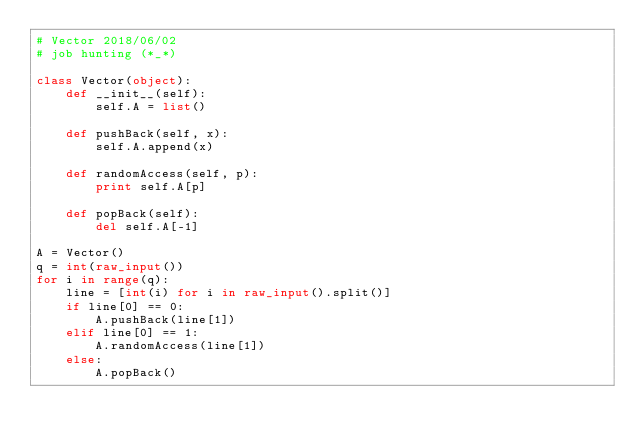Convert code to text. <code><loc_0><loc_0><loc_500><loc_500><_Python_># Vector 2018/06/02
# job hunting (*_*)

class Vector(object):
    def __init__(self):
        self.A = list()

    def pushBack(self, x):
        self.A.append(x)

    def randomAccess(self, p):
        print self.A[p]

    def popBack(self):
        del self.A[-1]

A = Vector()
q = int(raw_input())
for i in range(q):
    line = [int(i) for i in raw_input().split()]
    if line[0] == 0:
        A.pushBack(line[1])
    elif line[0] == 1:
        A.randomAccess(line[1])
    else:
        A.popBack()

</code> 